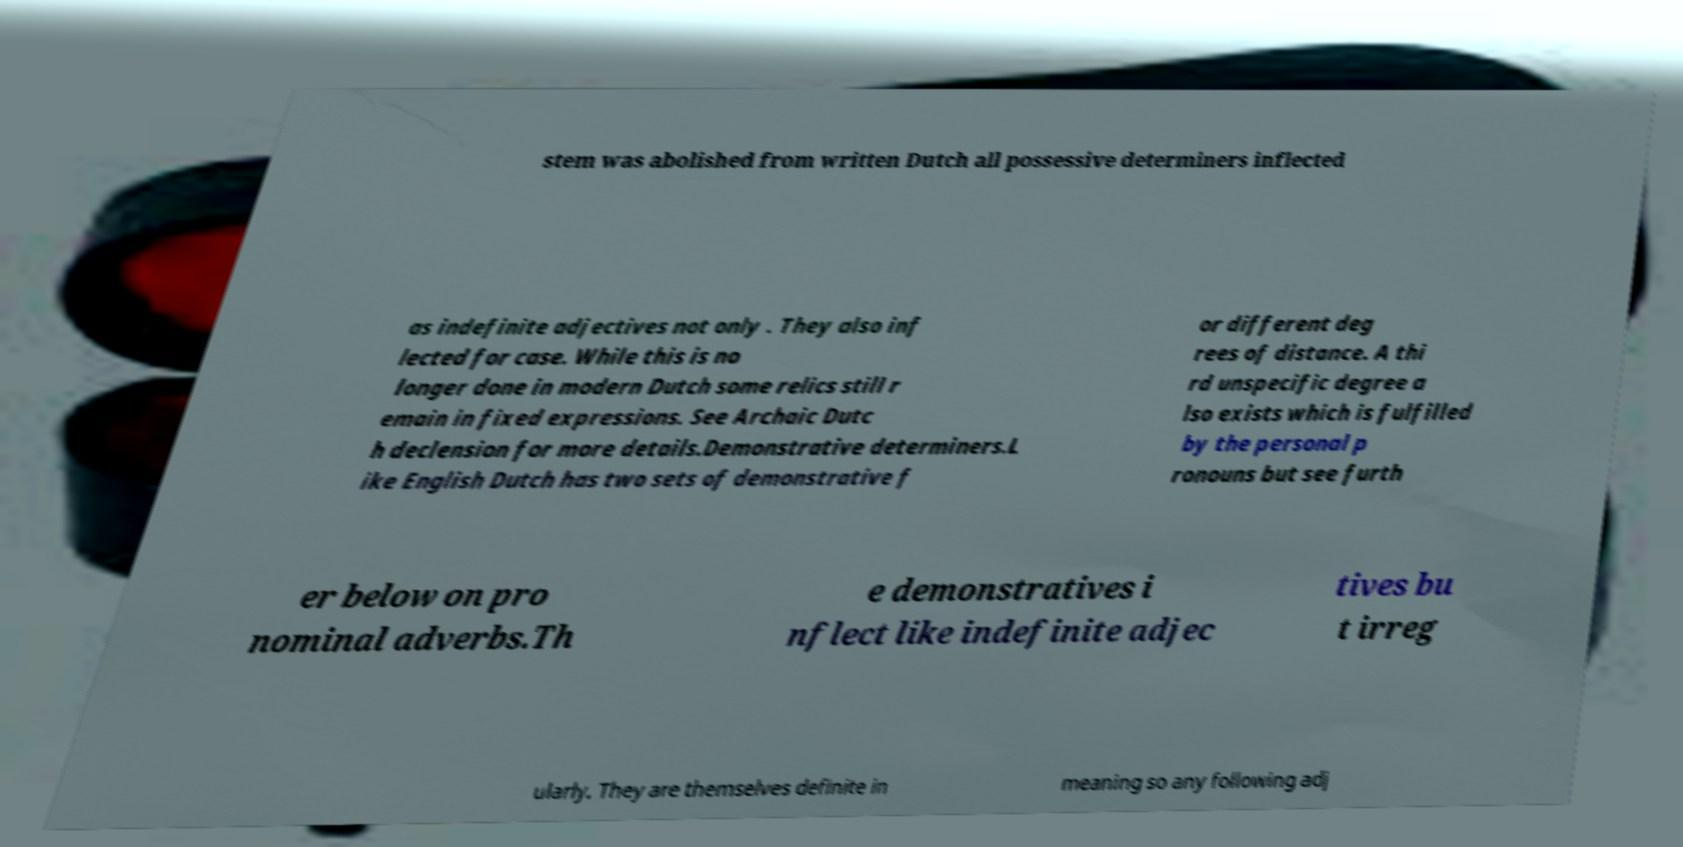Please read and relay the text visible in this image. What does it say? stem was abolished from written Dutch all possessive determiners inflected as indefinite adjectives not only . They also inf lected for case. While this is no longer done in modern Dutch some relics still r emain in fixed expressions. See Archaic Dutc h declension for more details.Demonstrative determiners.L ike English Dutch has two sets of demonstrative f or different deg rees of distance. A thi rd unspecific degree a lso exists which is fulfilled by the personal p ronouns but see furth er below on pro nominal adverbs.Th e demonstratives i nflect like indefinite adjec tives bu t irreg ularly. They are themselves definite in meaning so any following adj 